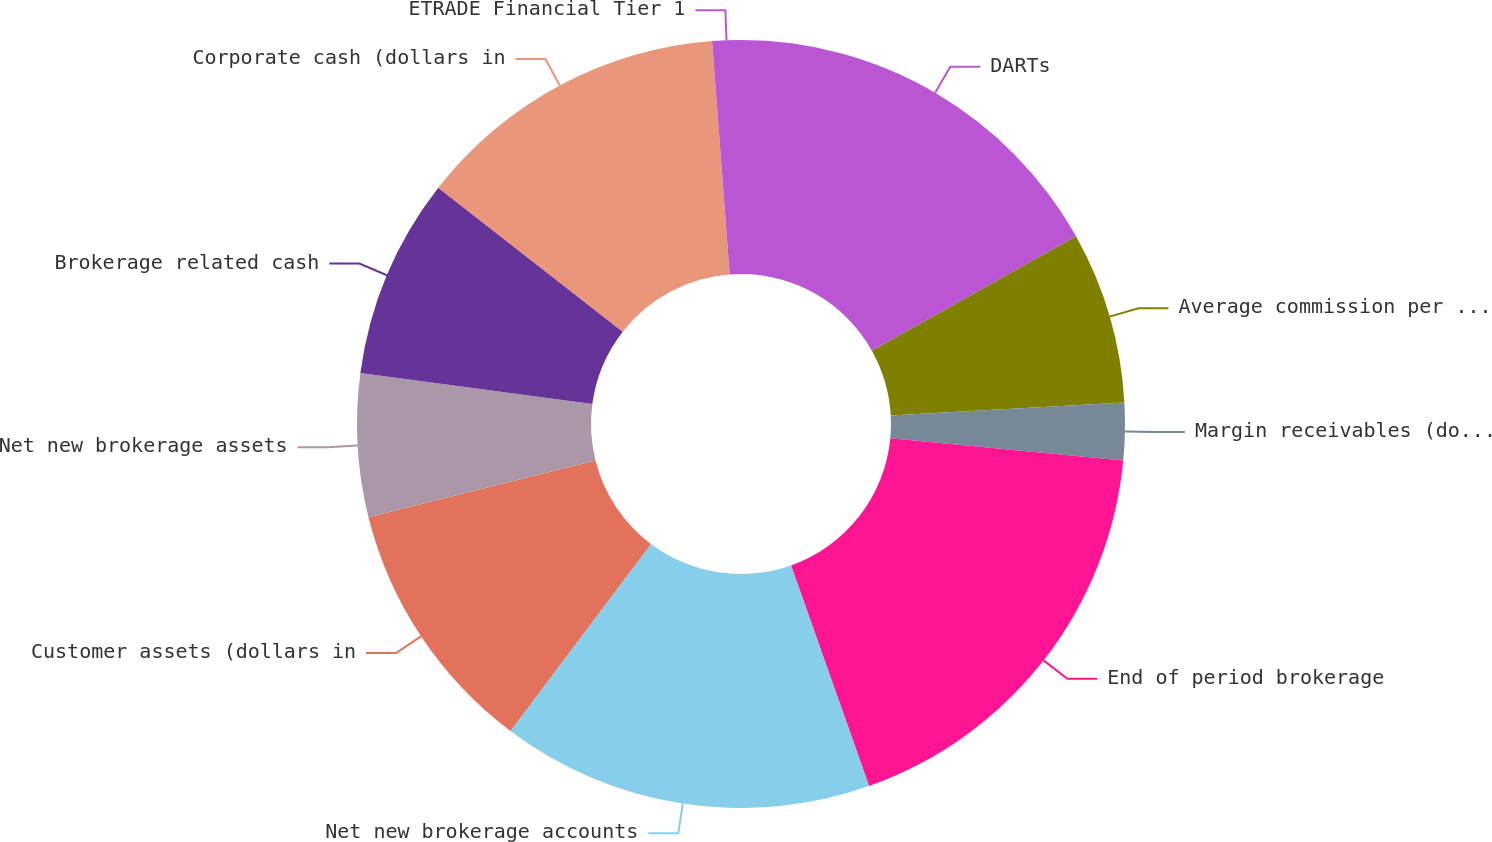<chart> <loc_0><loc_0><loc_500><loc_500><pie_chart><fcel>DARTs<fcel>Average commission per trade<fcel>Margin receivables (dollars in<fcel>End of period brokerage<fcel>Net new brokerage accounts<fcel>Customer assets (dollars in<fcel>Net new brokerage assets<fcel>Brokerage related cash<fcel>Corporate cash (dollars in<fcel>ETRADE Financial Tier 1<nl><fcel>16.87%<fcel>7.23%<fcel>2.41%<fcel>18.07%<fcel>15.66%<fcel>10.84%<fcel>6.02%<fcel>8.43%<fcel>13.25%<fcel>1.2%<nl></chart> 